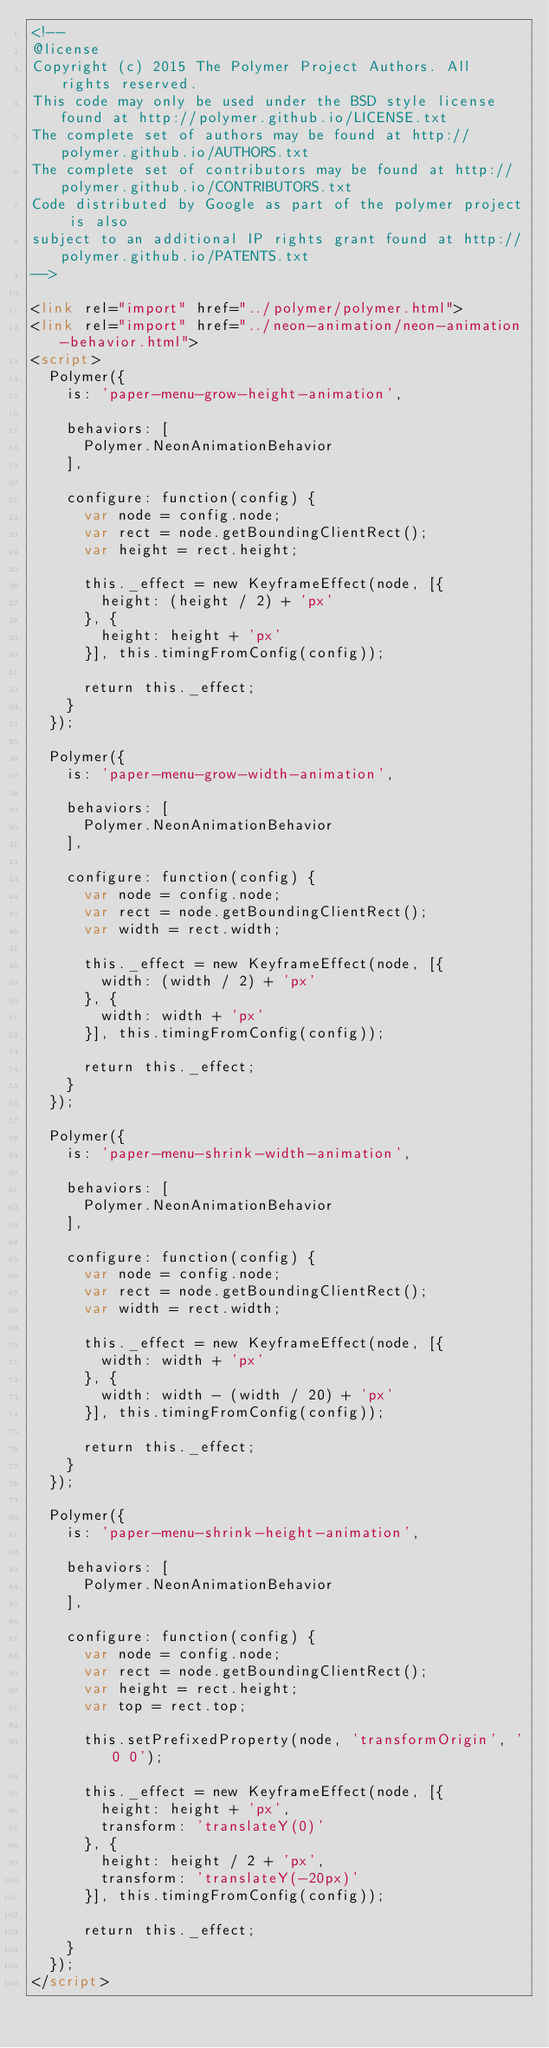Convert code to text. <code><loc_0><loc_0><loc_500><loc_500><_HTML_><!--
@license
Copyright (c) 2015 The Polymer Project Authors. All rights reserved.
This code may only be used under the BSD style license found at http://polymer.github.io/LICENSE.txt
The complete set of authors may be found at http://polymer.github.io/AUTHORS.txt
The complete set of contributors may be found at http://polymer.github.io/CONTRIBUTORS.txt
Code distributed by Google as part of the polymer project is also
subject to an additional IP rights grant found at http://polymer.github.io/PATENTS.txt
-->

<link rel="import" href="../polymer/polymer.html">
<link rel="import" href="../neon-animation/neon-animation-behavior.html">
<script>
  Polymer({
    is: 'paper-menu-grow-height-animation',

    behaviors: [
      Polymer.NeonAnimationBehavior
    ],

    configure: function(config) {
      var node = config.node;
      var rect = node.getBoundingClientRect();
      var height = rect.height;

      this._effect = new KeyframeEffect(node, [{
        height: (height / 2) + 'px'
      }, {
        height: height + 'px'
      }], this.timingFromConfig(config));

      return this._effect;
    }
  });

  Polymer({
    is: 'paper-menu-grow-width-animation',

    behaviors: [
      Polymer.NeonAnimationBehavior
    ],

    configure: function(config) {
      var node = config.node;
      var rect = node.getBoundingClientRect();
      var width = rect.width;

      this._effect = new KeyframeEffect(node, [{
        width: (width / 2) + 'px'
      }, {
        width: width + 'px'
      }], this.timingFromConfig(config));

      return this._effect;
    }
  });

  Polymer({
    is: 'paper-menu-shrink-width-animation',

    behaviors: [
      Polymer.NeonAnimationBehavior
    ],

    configure: function(config) {
      var node = config.node;
      var rect = node.getBoundingClientRect();
      var width = rect.width;

      this._effect = new KeyframeEffect(node, [{
        width: width + 'px'
      }, {
        width: width - (width / 20) + 'px'
      }], this.timingFromConfig(config));

      return this._effect;
    }
  });

  Polymer({
    is: 'paper-menu-shrink-height-animation',

    behaviors: [
      Polymer.NeonAnimationBehavior
    ],

    configure: function(config) {
      var node = config.node;
      var rect = node.getBoundingClientRect();
      var height = rect.height;
      var top = rect.top;

      this.setPrefixedProperty(node, 'transformOrigin', '0 0');

      this._effect = new KeyframeEffect(node, [{
        height: height + 'px',
        transform: 'translateY(0)'
      }, {
        height: height / 2 + 'px',
        transform: 'translateY(-20px)'
      }], this.timingFromConfig(config));

      return this._effect;
    }
  });
</script>


</code> 